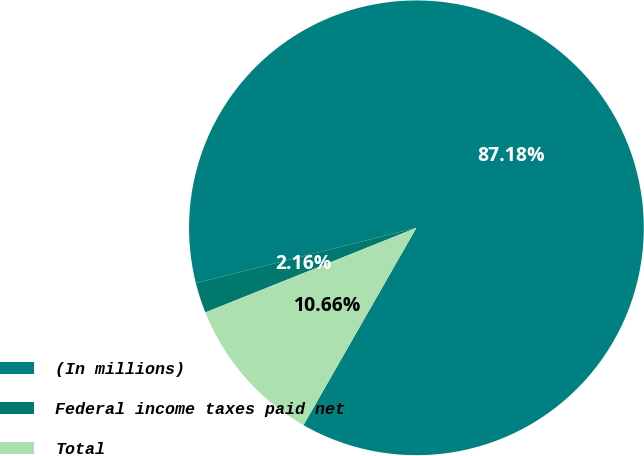<chart> <loc_0><loc_0><loc_500><loc_500><pie_chart><fcel>(In millions)<fcel>Federal income taxes paid net<fcel>Total<nl><fcel>87.18%<fcel>2.16%<fcel>10.66%<nl></chart> 